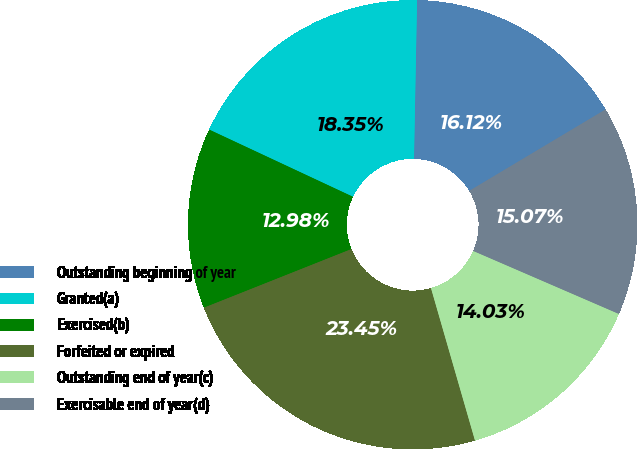<chart> <loc_0><loc_0><loc_500><loc_500><pie_chart><fcel>Outstanding beginning of year<fcel>Granted(a)<fcel>Exercised(b)<fcel>Forfeited or expired<fcel>Outstanding end of year(c)<fcel>Exercisable end of year(d)<nl><fcel>16.12%<fcel>18.35%<fcel>12.98%<fcel>23.45%<fcel>14.03%<fcel>15.07%<nl></chart> 